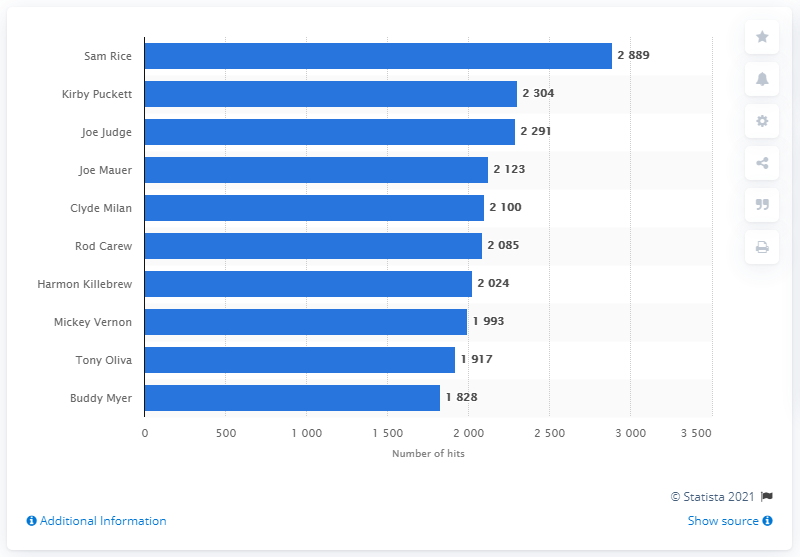Give some essential details in this illustration. The Minnesota Twins franchise has seen many talented players throughout its history, but none have hit more than Sam Rice. 